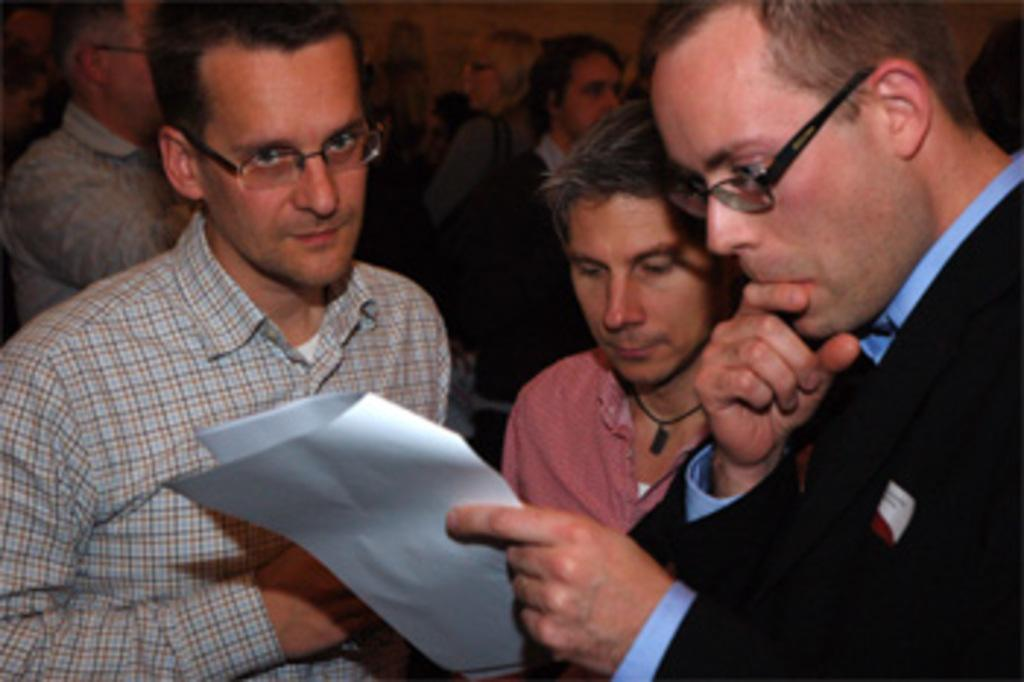How many people are in the image? There is a group of people in the image. What is one person in the group holding? One person is holding a paper in their hands. Reasoning: Let' Let's think step by step in order to produce the conversation. We start by acknowledging the presence of a group of people in the image. Then, we focus on a specific detail about one person in the group, which is that they are holding a paper. By asking these questions, we are able to provide information about the image based on the provided facts without making any assumptions or referring to a list of facts. Absurd Question/Answer: What type of tree is growing in the middle of the group of people? There is no tree present in the image; it only shows a group of people and one person holding a paper. 